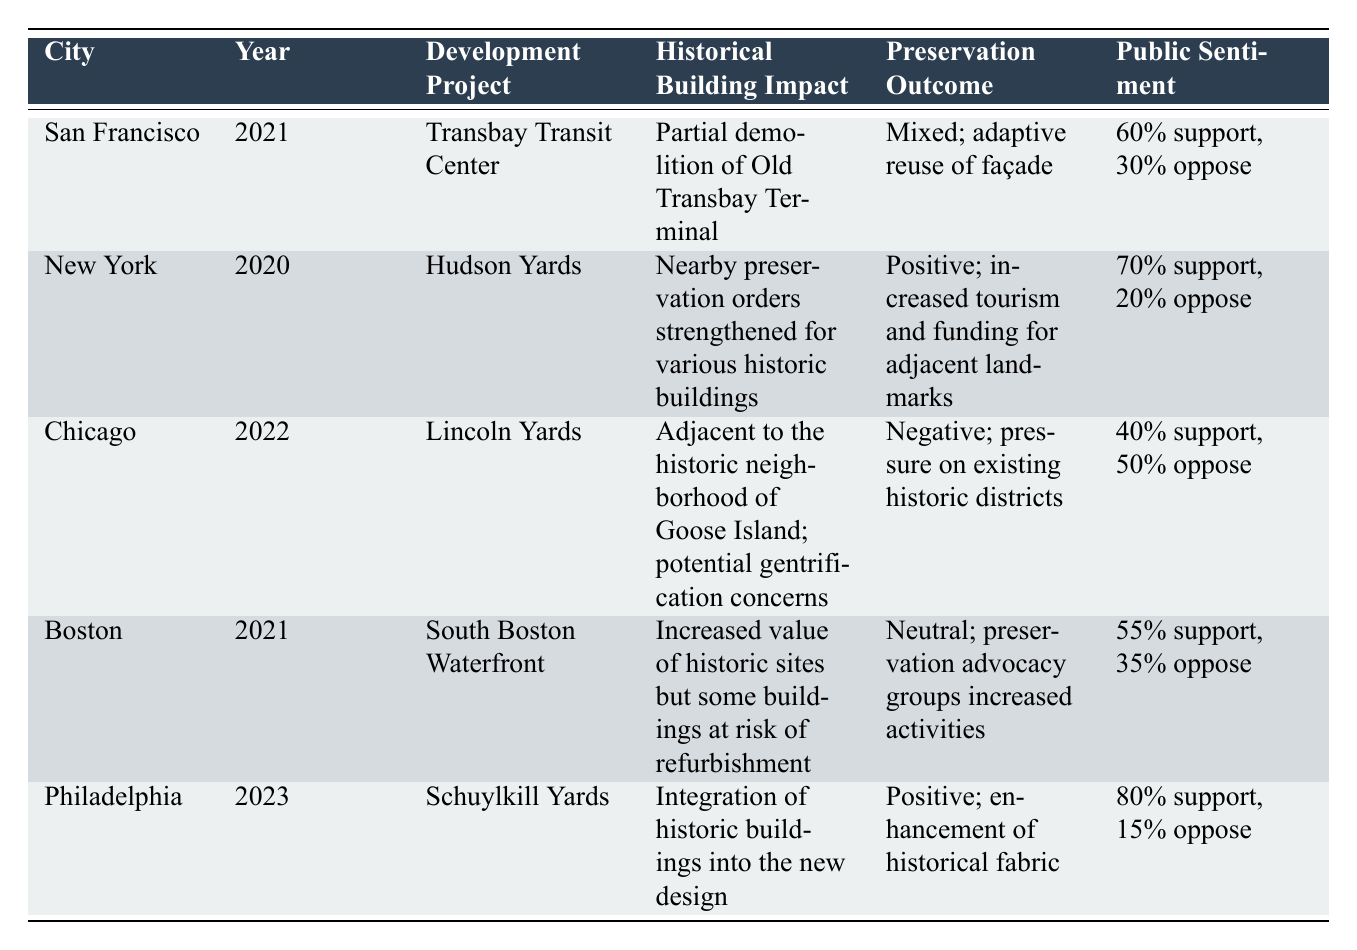What is the Historical Building Impact of the Schuylkill Yards project in Philadelphia? The table indicates that the Historical Building Impact for the Schuylkill Yards project is the integration of historic buildings into the new design.
Answer: Integration of historic buildings into the new design Which city had a development project in 2021 that resulted in a mixed preservation outcome? The development project in San Francisco, Transbay Transit Center, had a mixed preservation outcome noted in the table.
Answer: San Francisco What is the Public Sentiment percentage for the Lincoln Yards project in Chicago? Referring to the table, the Public Sentiment for Lincoln Yards is 40% support and 50% oppose.
Answer: 40% support, 50% oppose Did the Hudson Yards project in New York lead to a positive preservation outcome? Yes, according to the table, the preservation outcome for Hudson Yards is positive, with increased tourism and funding for adjacent landmarks.
Answer: Yes What city has the highest public support for urban development affecting historical buildings? By comparing the Public Sentiment percentages in the table, Philadelphia has the highest public support at 80%.
Answer: Philadelphia Which development project had a negative preservation outcome and why? Lincoln Yards in Chicago had a negative preservation outcome due to pressure on existing historic districts, as per the table.
Answer: Lincoln Yards; pressure on existing historic districts Is there any project with a neutral preservation outcome mentioned in the table? Yes, the South Boston Waterfront project in Boston is noted to have a neutral preservation outcome.
Answer: Yes What was the average public support percentage across all cities listed? To find the average: (60 + 70 + 40 + 55 + 80) / 5 = 61. The average public support percentage is 61%.
Answer: 61% Which city's development project resulted in historical preservation orders being strengthened? The table states that the Hudson Yards project in New York resulted in strengthened preservation orders for various historic buildings.
Answer: New York 